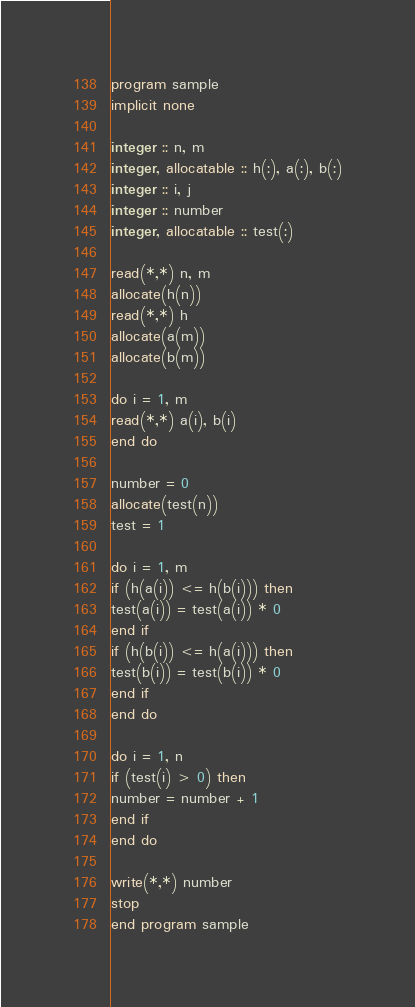Convert code to text. <code><loc_0><loc_0><loc_500><loc_500><_FORTRAN_>program sample
implicit none

integer :: n, m
integer, allocatable :: h(:), a(:), b(:)
integer :: i, j
integer :: number
integer, allocatable :: test(:)

read(*,*) n, m
allocate(h(n))
read(*,*) h
allocate(a(m))
allocate(b(m))

do i = 1, m
read(*,*) a(i), b(i)
end do

number = 0
allocate(test(n))
test = 1

do i = 1, m
if (h(a(i)) <= h(b(i))) then
test(a(i)) = test(a(i)) * 0
end if
if (h(b(i)) <= h(a(i))) then
test(b(i)) = test(b(i)) * 0
end if
end do

do i = 1, n
if (test(i) > 0) then
number = number + 1
end if
end do

write(*,*) number
stop
end program sample</code> 